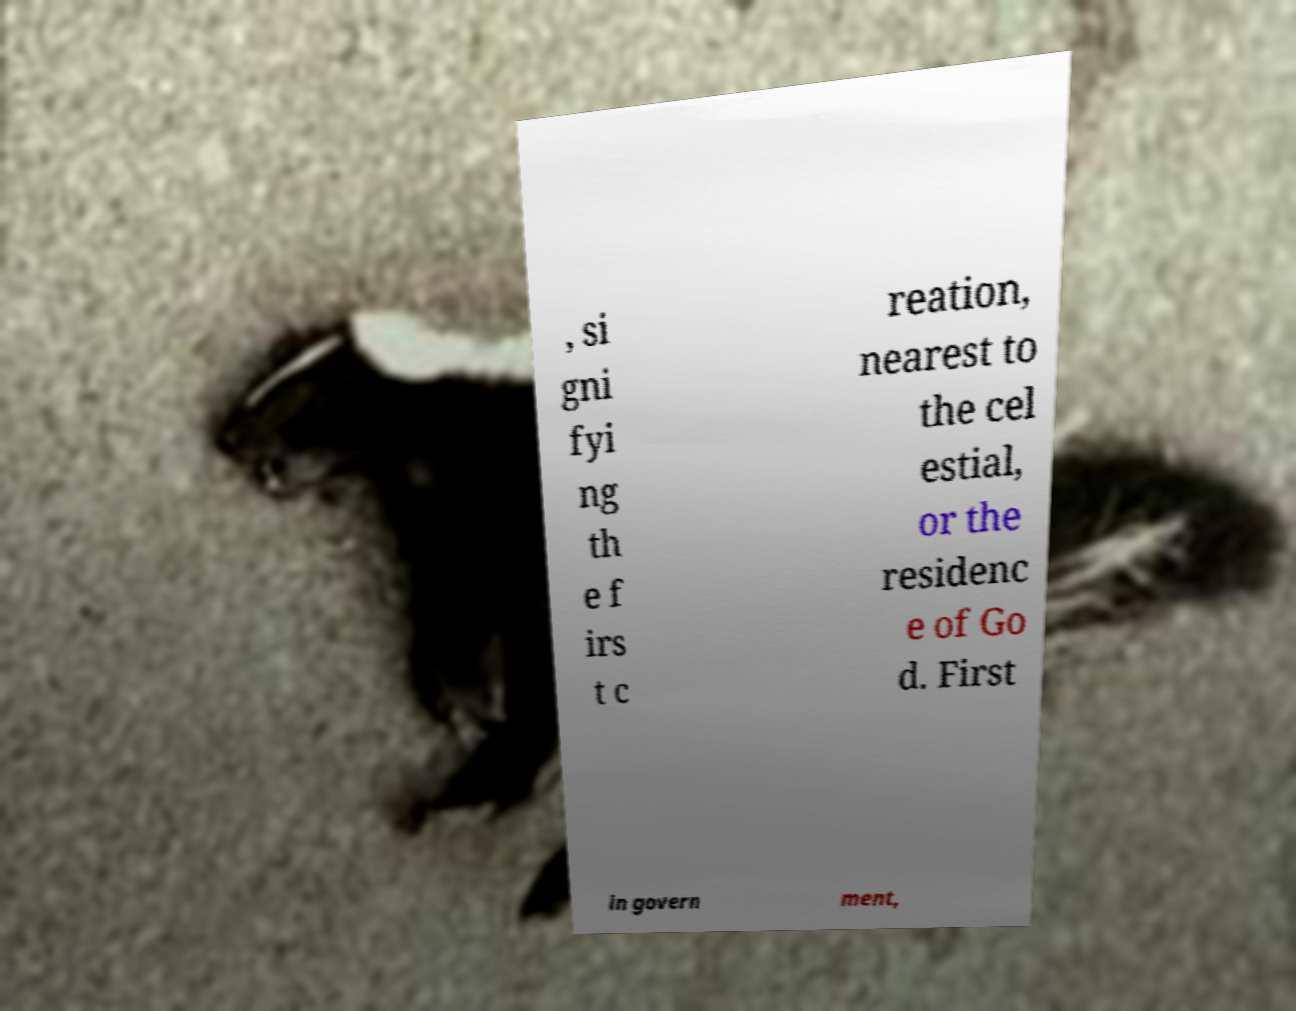Could you assist in decoding the text presented in this image and type it out clearly? , si gni fyi ng th e f irs t c reation, nearest to the cel estial, or the residenc e of Go d. First in govern ment, 